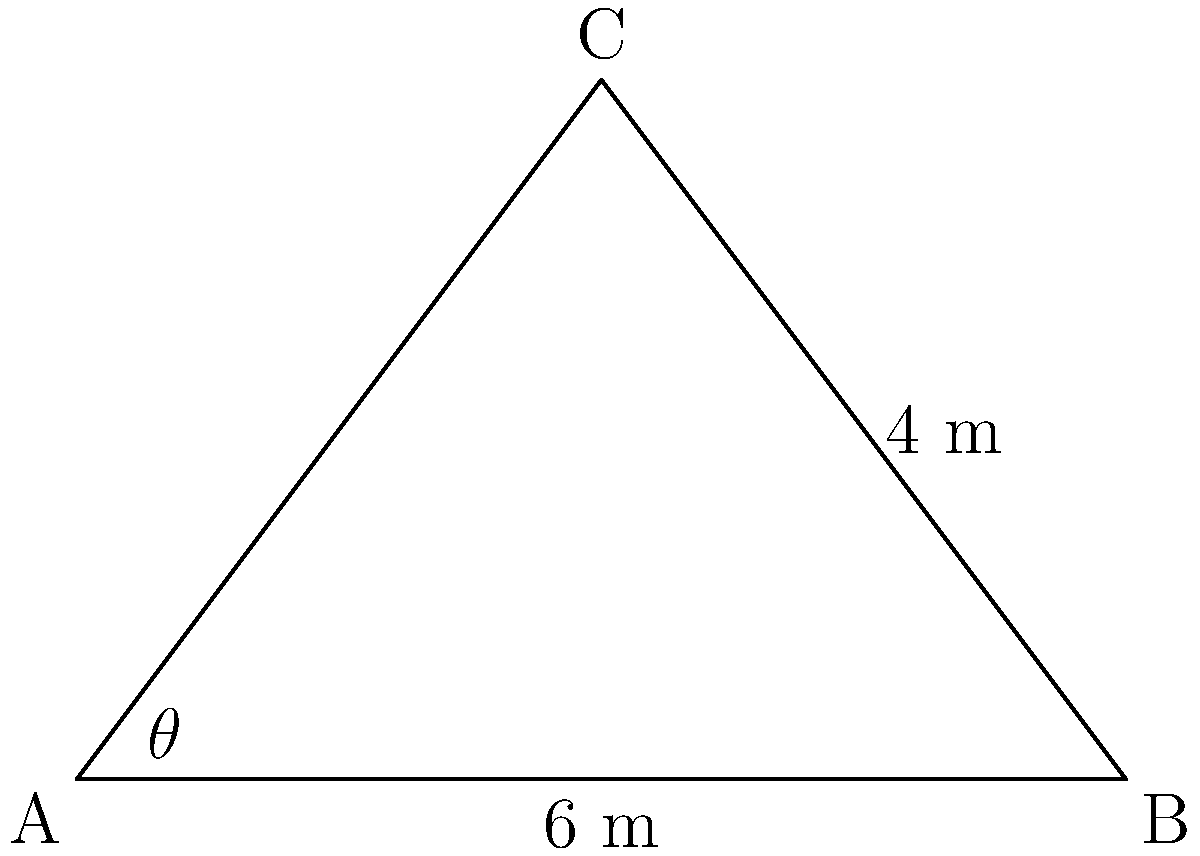For a new patient privacy-focused medical facility, you need to calculate the area of a triangular plot. The plot has a base of 6 meters and a height of 4 meters. If the angle $\theta$ at point A is 53.13°, what is the area of the triangular plot in square meters? To solve this problem, we'll use the formula for the area of a triangle:

1) The formula for the area of a triangle is:
   $A = \frac{1}{2} \times base \times height$

2) We're given:
   base = 6 meters
   height = 4 meters

3) Substituting these values into the formula:
   $A = \frac{1}{2} \times 6 \times 4$

4) Simplifying:
   $A = 3 \times 4 = 12$

Note: The angle $\theta$ given in the question (53.13°) is not needed for this calculation. It's provided as a distractor, as the area of a triangle can be calculated using just the base and height, regardless of the angles.
Answer: 12 m² 